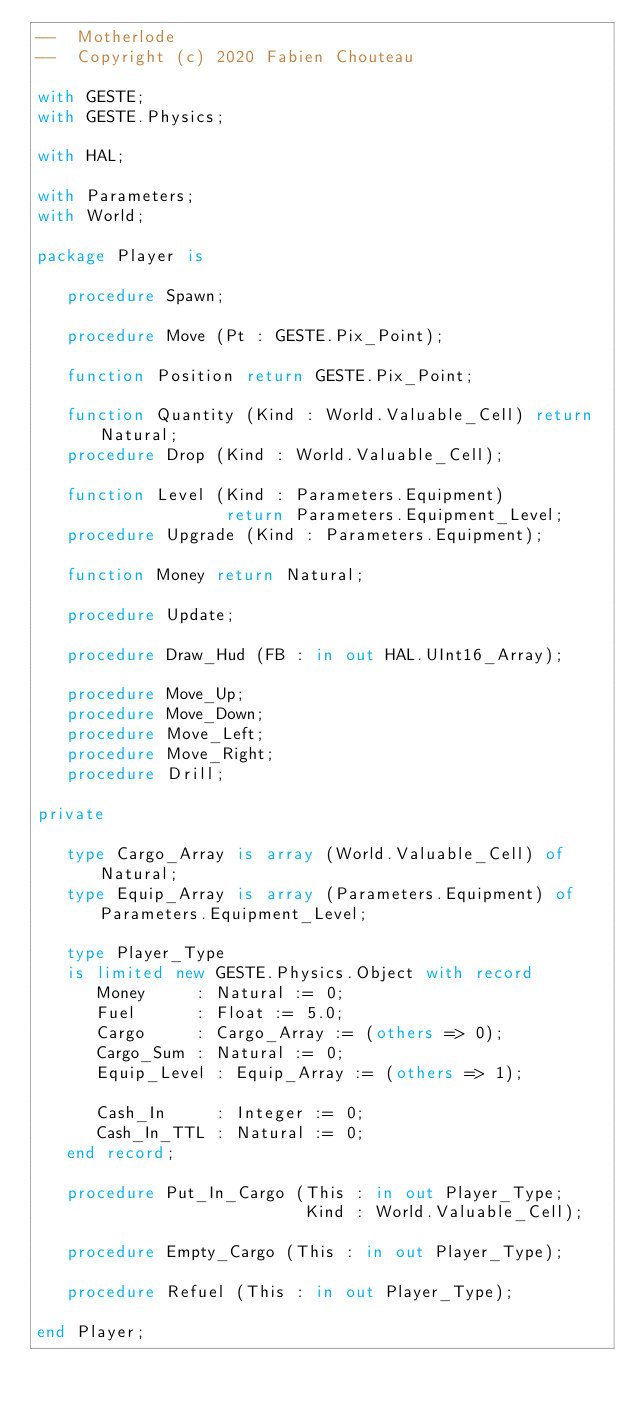Convert code to text. <code><loc_0><loc_0><loc_500><loc_500><_Ada_>--  Motherlode
--  Copyright (c) 2020 Fabien Chouteau

with GESTE;
with GESTE.Physics;

with HAL;

with Parameters;
with World;

package Player is

   procedure Spawn;

   procedure Move (Pt : GESTE.Pix_Point);

   function Position return GESTE.Pix_Point;

   function Quantity (Kind : World.Valuable_Cell) return Natural;
   procedure Drop (Kind : World.Valuable_Cell);

   function Level (Kind : Parameters.Equipment)
                   return Parameters.Equipment_Level;
   procedure Upgrade (Kind : Parameters.Equipment);

   function Money return Natural;

   procedure Update;

   procedure Draw_Hud (FB : in out HAL.UInt16_Array);

   procedure Move_Up;
   procedure Move_Down;
   procedure Move_Left;
   procedure Move_Right;
   procedure Drill;

private

   type Cargo_Array is array (World.Valuable_Cell) of Natural;
   type Equip_Array is array (Parameters.Equipment) of Parameters.Equipment_Level;

   type Player_Type
   is limited new GESTE.Physics.Object with record
      Money     : Natural := 0;
      Fuel      : Float := 5.0;
      Cargo     : Cargo_Array := (others => 0);
      Cargo_Sum : Natural := 0;
      Equip_Level : Equip_Array := (others => 1);

      Cash_In     : Integer := 0;
      Cash_In_TTL : Natural := 0;
   end record;

   procedure Put_In_Cargo (This : in out Player_Type;
                           Kind : World.Valuable_Cell);

   procedure Empty_Cargo (This : in out Player_Type);

   procedure Refuel (This : in out Player_Type);

end Player;
</code> 